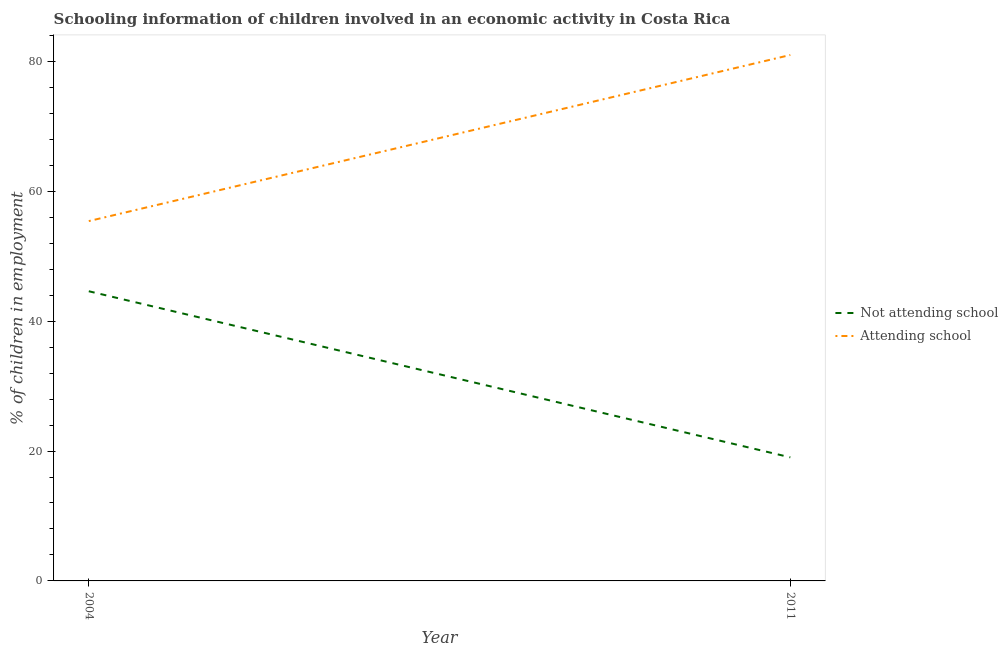Is the number of lines equal to the number of legend labels?
Your answer should be very brief. Yes. What is the percentage of employed children who are not attending school in 2004?
Your answer should be very brief. 44.6. Across all years, what is the maximum percentage of employed children who are attending school?
Provide a short and direct response. 80.98. Across all years, what is the minimum percentage of employed children who are not attending school?
Make the answer very short. 19.02. What is the total percentage of employed children who are not attending school in the graph?
Give a very brief answer. 63.62. What is the difference between the percentage of employed children who are not attending school in 2004 and that in 2011?
Keep it short and to the point. 25.58. What is the difference between the percentage of employed children who are not attending school in 2011 and the percentage of employed children who are attending school in 2004?
Provide a succinct answer. -36.38. What is the average percentage of employed children who are attending school per year?
Your answer should be compact. 68.19. In the year 2004, what is the difference between the percentage of employed children who are not attending school and percentage of employed children who are attending school?
Provide a short and direct response. -10.8. What is the ratio of the percentage of employed children who are not attending school in 2004 to that in 2011?
Give a very brief answer. 2.34. Is the percentage of employed children who are not attending school in 2004 less than that in 2011?
Your answer should be very brief. No. In how many years, is the percentage of employed children who are not attending school greater than the average percentage of employed children who are not attending school taken over all years?
Offer a terse response. 1. Does the percentage of employed children who are not attending school monotonically increase over the years?
Keep it short and to the point. No. Is the percentage of employed children who are not attending school strictly less than the percentage of employed children who are attending school over the years?
Ensure brevity in your answer.  Yes. How many years are there in the graph?
Give a very brief answer. 2. Where does the legend appear in the graph?
Provide a short and direct response. Center right. How many legend labels are there?
Provide a short and direct response. 2. What is the title of the graph?
Give a very brief answer. Schooling information of children involved in an economic activity in Costa Rica. What is the label or title of the X-axis?
Give a very brief answer. Year. What is the label or title of the Y-axis?
Keep it short and to the point. % of children in employment. What is the % of children in employment of Not attending school in 2004?
Make the answer very short. 44.6. What is the % of children in employment in Attending school in 2004?
Ensure brevity in your answer.  55.4. What is the % of children in employment in Not attending school in 2011?
Your response must be concise. 19.02. What is the % of children in employment in Attending school in 2011?
Ensure brevity in your answer.  80.98. Across all years, what is the maximum % of children in employment of Not attending school?
Offer a very short reply. 44.6. Across all years, what is the maximum % of children in employment in Attending school?
Your response must be concise. 80.98. Across all years, what is the minimum % of children in employment of Not attending school?
Provide a short and direct response. 19.02. Across all years, what is the minimum % of children in employment of Attending school?
Make the answer very short. 55.4. What is the total % of children in employment of Not attending school in the graph?
Offer a terse response. 63.62. What is the total % of children in employment of Attending school in the graph?
Keep it short and to the point. 136.38. What is the difference between the % of children in employment in Not attending school in 2004 and that in 2011?
Make the answer very short. 25.58. What is the difference between the % of children in employment in Attending school in 2004 and that in 2011?
Your response must be concise. -25.58. What is the difference between the % of children in employment of Not attending school in 2004 and the % of children in employment of Attending school in 2011?
Your answer should be very brief. -36.38. What is the average % of children in employment in Not attending school per year?
Provide a succinct answer. 31.81. What is the average % of children in employment in Attending school per year?
Offer a terse response. 68.19. In the year 2011, what is the difference between the % of children in employment of Not attending school and % of children in employment of Attending school?
Provide a succinct answer. -61.95. What is the ratio of the % of children in employment of Not attending school in 2004 to that in 2011?
Make the answer very short. 2.34. What is the ratio of the % of children in employment of Attending school in 2004 to that in 2011?
Your response must be concise. 0.68. What is the difference between the highest and the second highest % of children in employment of Not attending school?
Keep it short and to the point. 25.58. What is the difference between the highest and the second highest % of children in employment of Attending school?
Provide a short and direct response. 25.58. What is the difference between the highest and the lowest % of children in employment in Not attending school?
Offer a very short reply. 25.58. What is the difference between the highest and the lowest % of children in employment in Attending school?
Keep it short and to the point. 25.58. 